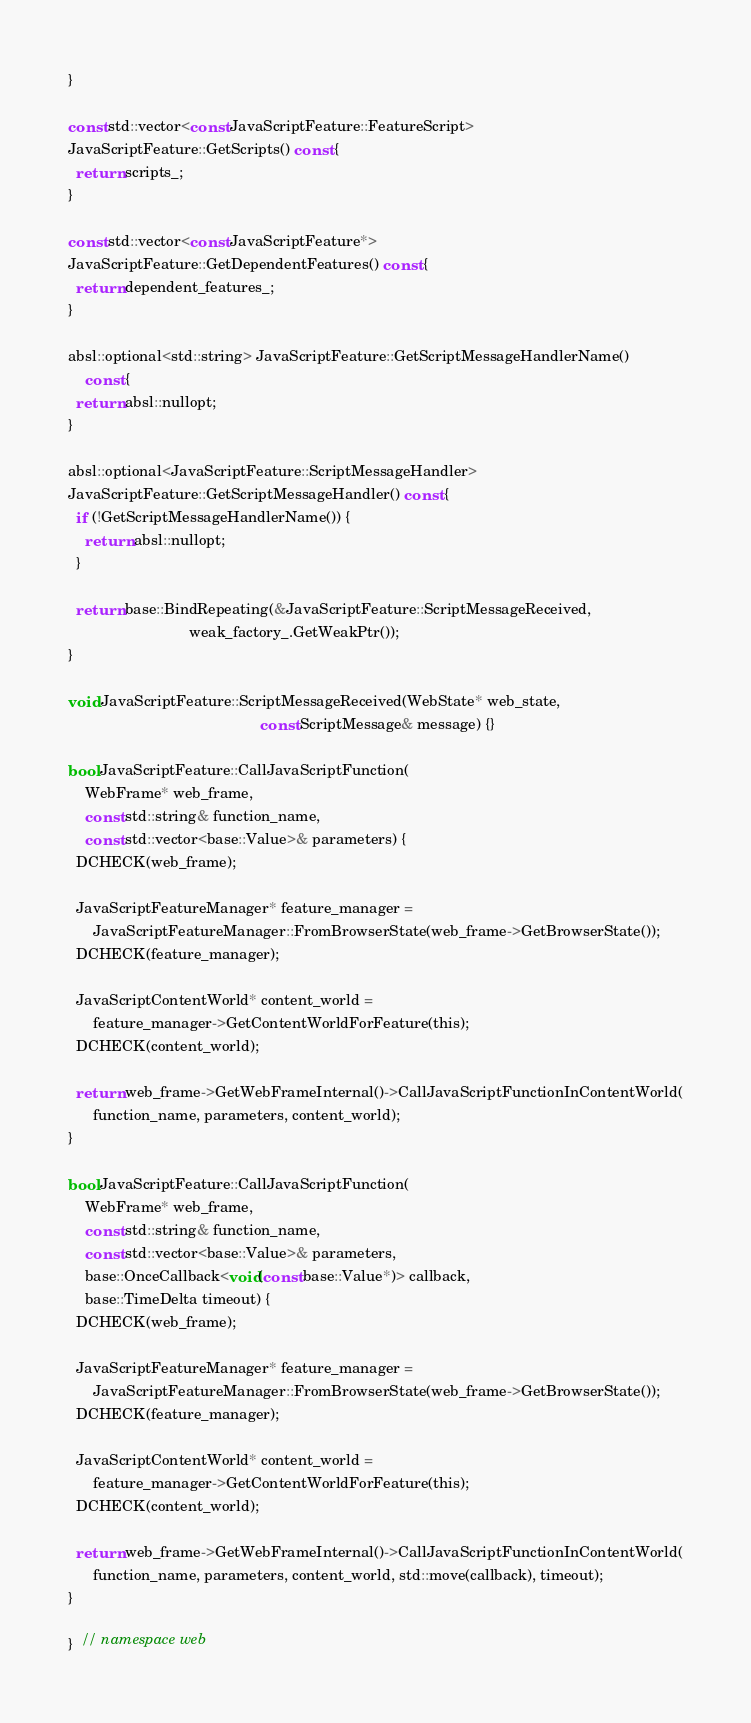Convert code to text. <code><loc_0><loc_0><loc_500><loc_500><_ObjectiveC_>}

const std::vector<const JavaScriptFeature::FeatureScript>
JavaScriptFeature::GetScripts() const {
  return scripts_;
}

const std::vector<const JavaScriptFeature*>
JavaScriptFeature::GetDependentFeatures() const {
  return dependent_features_;
}

absl::optional<std::string> JavaScriptFeature::GetScriptMessageHandlerName()
    const {
  return absl::nullopt;
}

absl::optional<JavaScriptFeature::ScriptMessageHandler>
JavaScriptFeature::GetScriptMessageHandler() const {
  if (!GetScriptMessageHandlerName()) {
    return absl::nullopt;
  }

  return base::BindRepeating(&JavaScriptFeature::ScriptMessageReceived,
                             weak_factory_.GetWeakPtr());
}

void JavaScriptFeature::ScriptMessageReceived(WebState* web_state,
                                              const ScriptMessage& message) {}

bool JavaScriptFeature::CallJavaScriptFunction(
    WebFrame* web_frame,
    const std::string& function_name,
    const std::vector<base::Value>& parameters) {
  DCHECK(web_frame);

  JavaScriptFeatureManager* feature_manager =
      JavaScriptFeatureManager::FromBrowserState(web_frame->GetBrowserState());
  DCHECK(feature_manager);

  JavaScriptContentWorld* content_world =
      feature_manager->GetContentWorldForFeature(this);
  DCHECK(content_world);

  return web_frame->GetWebFrameInternal()->CallJavaScriptFunctionInContentWorld(
      function_name, parameters, content_world);
}

bool JavaScriptFeature::CallJavaScriptFunction(
    WebFrame* web_frame,
    const std::string& function_name,
    const std::vector<base::Value>& parameters,
    base::OnceCallback<void(const base::Value*)> callback,
    base::TimeDelta timeout) {
  DCHECK(web_frame);

  JavaScriptFeatureManager* feature_manager =
      JavaScriptFeatureManager::FromBrowserState(web_frame->GetBrowserState());
  DCHECK(feature_manager);

  JavaScriptContentWorld* content_world =
      feature_manager->GetContentWorldForFeature(this);
  DCHECK(content_world);

  return web_frame->GetWebFrameInternal()->CallJavaScriptFunctionInContentWorld(
      function_name, parameters, content_world, std::move(callback), timeout);
}

}  // namespace web
</code> 